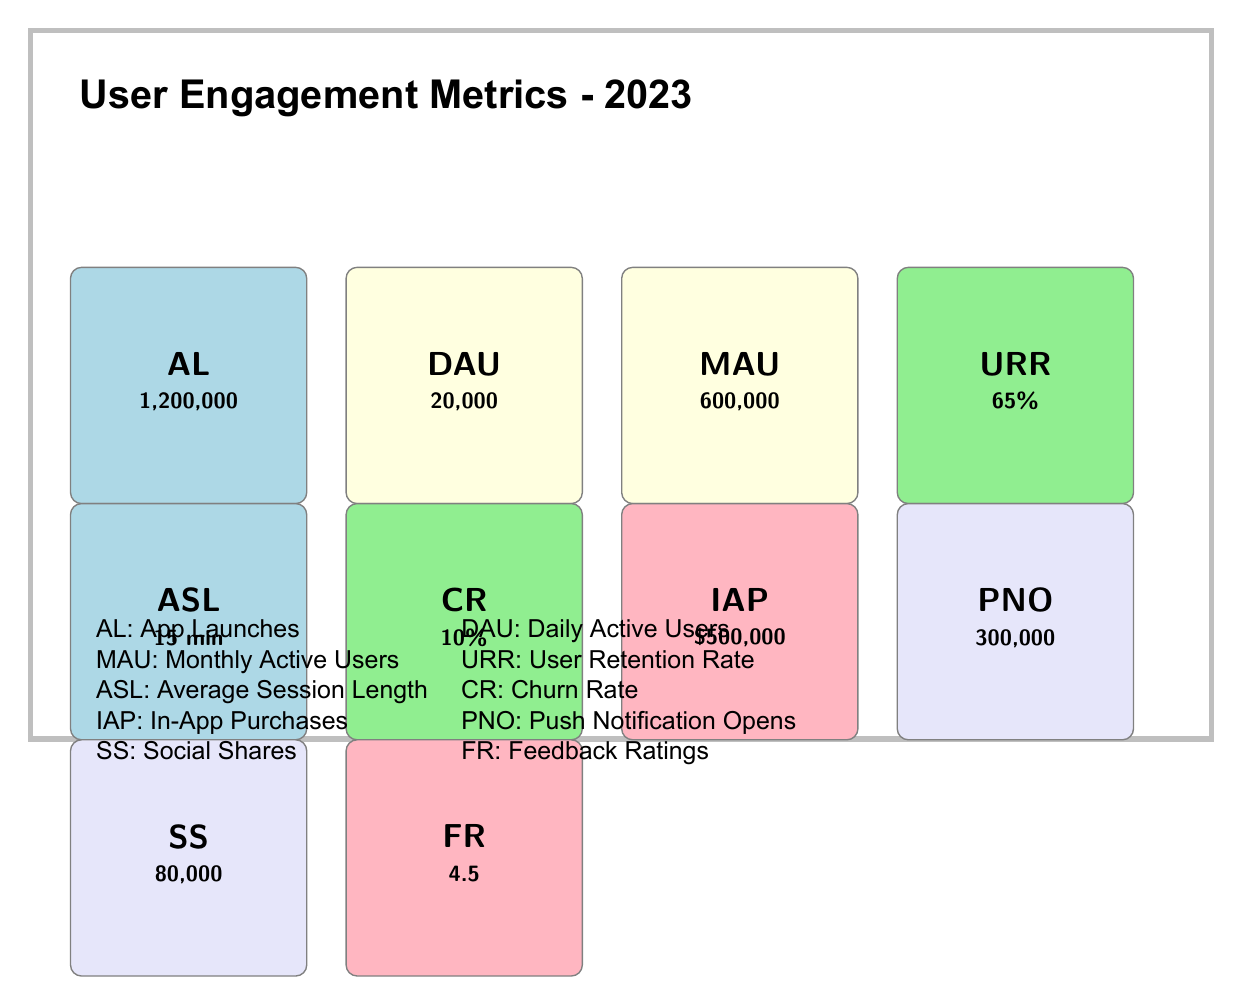What is the total number of app launches in 2023? The "App Launches" metric shows the total number of times the app was launched in 2023, which is clearly stated as 1,200,000 in the table.
Answer: 1,200,000 What percentage of users return to the app after their first visit? The "User Retention Rate" metric indicates the percentage of users who return to the app after their first visit, which is listed as 65% in the table.
Answer: 65% How many more daily active users are there compared to the churn rate? The number of Daily Active Users is 20,000, and the Churn Rate is 10%, which means we consider this as a percentage of users. Since Churn Rate doesn't convert directly to user count, we can't compare these two metrics directly in the context provided.
Answer: Cannot be determined What is the total count of social shares and push notification opens? To find the total, we add the "Social Shares" value of 80,000 and the "Push Notification Opens" value of 300,000: 80,000 + 300,000 = 380,000.
Answer: 380,000 Is the average user rating of the app higher than 4.0? The "Feedback Ratings" metric shows an average user rating of 4.5, which is indeed higher than 4.0, confirming a positive user experience.
Answer: Yes What is the average time spent in the app during a session? The "Average Session Length" metric indicates the average duration of user sessions in the app is stated as 15 minutes in the table.
Answer: 15 minutes If the number of monthly active users is 600,000, what is the ratio of daily active users (20,000) to monthly active users? We find the ratio by dividing the number of daily active users by the number of monthly active users: 20,000 / 600,000 = 1/30 or 0.0333, which indicates that about 3.33% of monthly active users engage daily.
Answer: 1/30 How many app launches occurred per daily active user? To find the app launches per daily active user, we take the total app launches (1,200,000) and divide it by the number of daily active users (20,000): 1,200,000 / 20,000 = 60. This means there were, on average, 60 app launches for each daily active user.
Answer: 60 What is the difference in values between in-app purchases and social shares? We determine this by subtracting the total social shares (80,000) from the total in-app purchases (500,000): 500,000 - 80,000 = 420,000, indicating a significant difference, suggesting that monetization may be strong compared to user engagement through sharing.
Answer: 420,000 